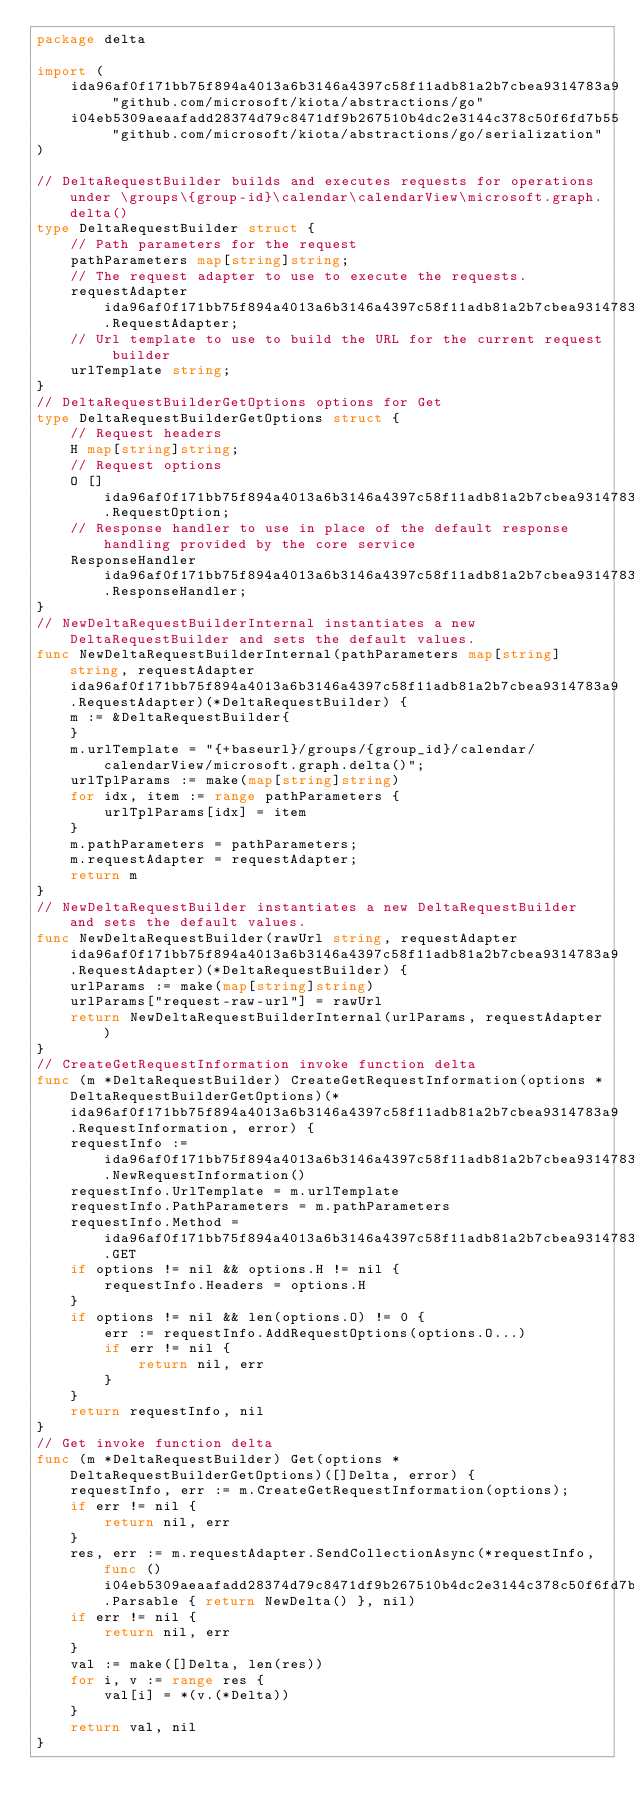Convert code to text. <code><loc_0><loc_0><loc_500><loc_500><_Go_>package delta

import (
    ida96af0f171bb75f894a4013a6b3146a4397c58f11adb81a2b7cbea9314783a9 "github.com/microsoft/kiota/abstractions/go"
    i04eb5309aeaafadd28374d79c8471df9b267510b4dc2e3144c378c50f6fd7b55 "github.com/microsoft/kiota/abstractions/go/serialization"
)

// DeltaRequestBuilder builds and executes requests for operations under \groups\{group-id}\calendar\calendarView\microsoft.graph.delta()
type DeltaRequestBuilder struct {
    // Path parameters for the request
    pathParameters map[string]string;
    // The request adapter to use to execute the requests.
    requestAdapter ida96af0f171bb75f894a4013a6b3146a4397c58f11adb81a2b7cbea9314783a9.RequestAdapter;
    // Url template to use to build the URL for the current request builder
    urlTemplate string;
}
// DeltaRequestBuilderGetOptions options for Get
type DeltaRequestBuilderGetOptions struct {
    // Request headers
    H map[string]string;
    // Request options
    O []ida96af0f171bb75f894a4013a6b3146a4397c58f11adb81a2b7cbea9314783a9.RequestOption;
    // Response handler to use in place of the default response handling provided by the core service
    ResponseHandler ida96af0f171bb75f894a4013a6b3146a4397c58f11adb81a2b7cbea9314783a9.ResponseHandler;
}
// NewDeltaRequestBuilderInternal instantiates a new DeltaRequestBuilder and sets the default values.
func NewDeltaRequestBuilderInternal(pathParameters map[string]string, requestAdapter ida96af0f171bb75f894a4013a6b3146a4397c58f11adb81a2b7cbea9314783a9.RequestAdapter)(*DeltaRequestBuilder) {
    m := &DeltaRequestBuilder{
    }
    m.urlTemplate = "{+baseurl}/groups/{group_id}/calendar/calendarView/microsoft.graph.delta()";
    urlTplParams := make(map[string]string)
    for idx, item := range pathParameters {
        urlTplParams[idx] = item
    }
    m.pathParameters = pathParameters;
    m.requestAdapter = requestAdapter;
    return m
}
// NewDeltaRequestBuilder instantiates a new DeltaRequestBuilder and sets the default values.
func NewDeltaRequestBuilder(rawUrl string, requestAdapter ida96af0f171bb75f894a4013a6b3146a4397c58f11adb81a2b7cbea9314783a9.RequestAdapter)(*DeltaRequestBuilder) {
    urlParams := make(map[string]string)
    urlParams["request-raw-url"] = rawUrl
    return NewDeltaRequestBuilderInternal(urlParams, requestAdapter)
}
// CreateGetRequestInformation invoke function delta
func (m *DeltaRequestBuilder) CreateGetRequestInformation(options *DeltaRequestBuilderGetOptions)(*ida96af0f171bb75f894a4013a6b3146a4397c58f11adb81a2b7cbea9314783a9.RequestInformation, error) {
    requestInfo := ida96af0f171bb75f894a4013a6b3146a4397c58f11adb81a2b7cbea9314783a9.NewRequestInformation()
    requestInfo.UrlTemplate = m.urlTemplate
    requestInfo.PathParameters = m.pathParameters
    requestInfo.Method = ida96af0f171bb75f894a4013a6b3146a4397c58f11adb81a2b7cbea9314783a9.GET
    if options != nil && options.H != nil {
        requestInfo.Headers = options.H
    }
    if options != nil && len(options.O) != 0 {
        err := requestInfo.AddRequestOptions(options.O...)
        if err != nil {
            return nil, err
        }
    }
    return requestInfo, nil
}
// Get invoke function delta
func (m *DeltaRequestBuilder) Get(options *DeltaRequestBuilderGetOptions)([]Delta, error) {
    requestInfo, err := m.CreateGetRequestInformation(options);
    if err != nil {
        return nil, err
    }
    res, err := m.requestAdapter.SendCollectionAsync(*requestInfo, func () i04eb5309aeaafadd28374d79c8471df9b267510b4dc2e3144c378c50f6fd7b55.Parsable { return NewDelta() }, nil)
    if err != nil {
        return nil, err
    }
    val := make([]Delta, len(res))
    for i, v := range res {
        val[i] = *(v.(*Delta))
    }
    return val, nil
}
</code> 